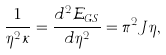Convert formula to latex. <formula><loc_0><loc_0><loc_500><loc_500>\frac { 1 } { \eta ^ { 2 } \kappa } = \frac { d ^ { 2 } \mathcal { E } _ { G S } } { d \eta ^ { 2 } } = \pi ^ { 2 } J \eta ,</formula> 